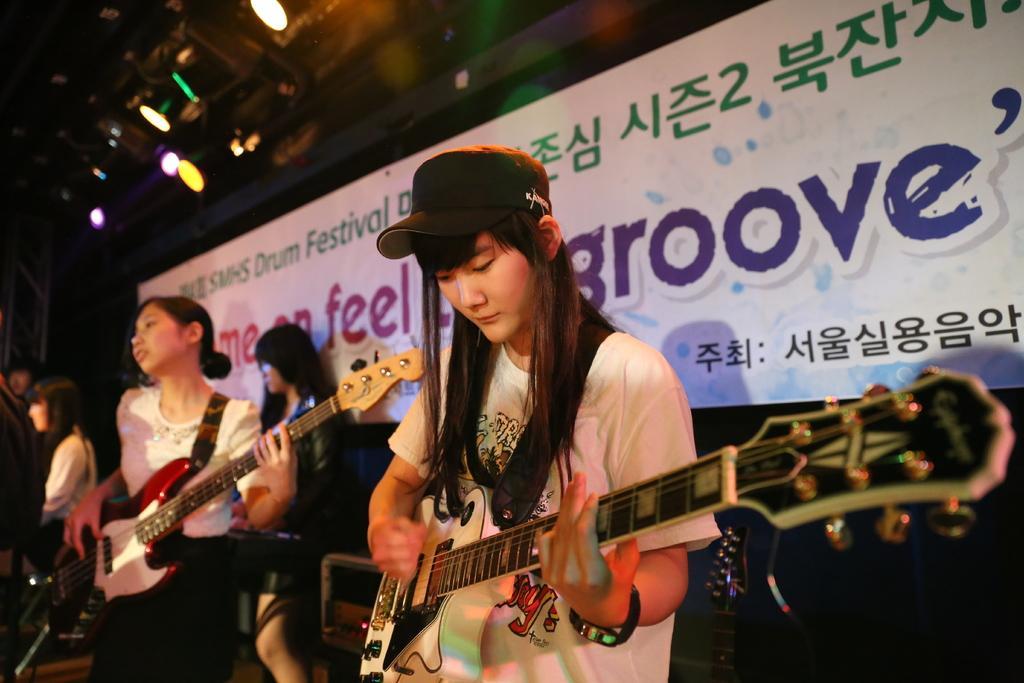Can you describe this image briefly? In this picture there are group of girls those who are playing the music on the stage and there is a flex behind them and there are spotlights above the area of the image, it seems to be they are performing a music event. 